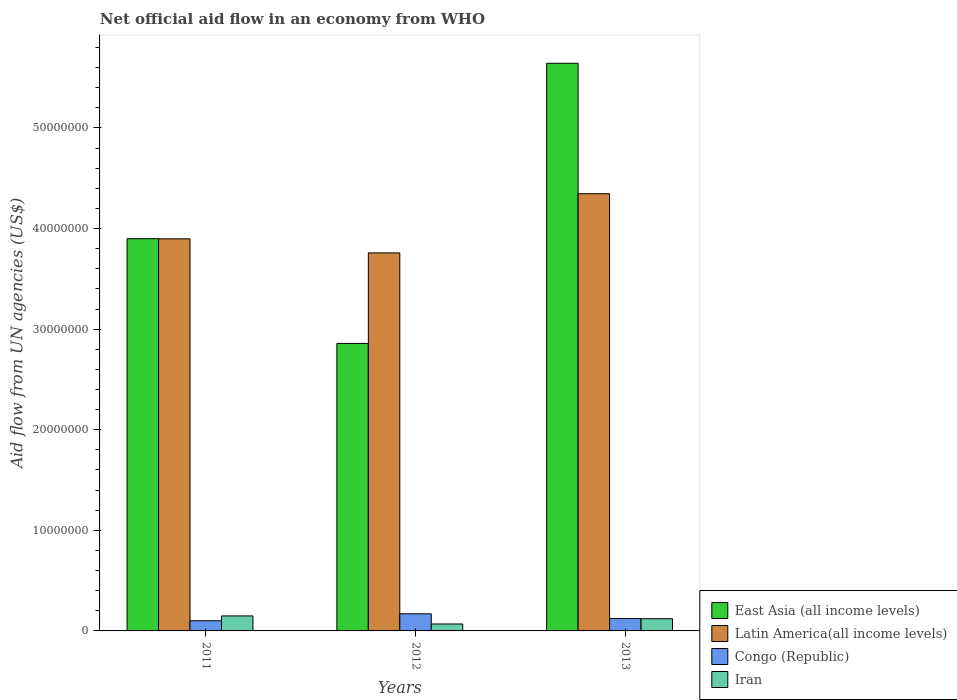How many different coloured bars are there?
Offer a terse response. 4. How many bars are there on the 1st tick from the right?
Your response must be concise. 4. What is the net official aid flow in Latin America(all income levels) in 2011?
Your answer should be compact. 3.90e+07. Across all years, what is the maximum net official aid flow in Iran?
Provide a succinct answer. 1.49e+06. Across all years, what is the minimum net official aid flow in Congo (Republic)?
Your answer should be very brief. 1.01e+06. In which year was the net official aid flow in Iran maximum?
Make the answer very short. 2011. In which year was the net official aid flow in Congo (Republic) minimum?
Your response must be concise. 2011. What is the total net official aid flow in Iran in the graph?
Your response must be concise. 3.39e+06. What is the difference between the net official aid flow in Congo (Republic) in 2011 and that in 2012?
Ensure brevity in your answer.  -6.90e+05. What is the difference between the net official aid flow in Congo (Republic) in 2011 and the net official aid flow in Latin America(all income levels) in 2012?
Provide a succinct answer. -3.66e+07. What is the average net official aid flow in East Asia (all income levels) per year?
Make the answer very short. 4.13e+07. In the year 2013, what is the difference between the net official aid flow in East Asia (all income levels) and net official aid flow in Iran?
Provide a short and direct response. 5.52e+07. What is the ratio of the net official aid flow in Latin America(all income levels) in 2011 to that in 2013?
Offer a very short reply. 0.9. Is the net official aid flow in East Asia (all income levels) in 2012 less than that in 2013?
Your response must be concise. Yes. Is the difference between the net official aid flow in East Asia (all income levels) in 2011 and 2013 greater than the difference between the net official aid flow in Iran in 2011 and 2013?
Keep it short and to the point. No. What is the difference between the highest and the second highest net official aid flow in Congo (Republic)?
Give a very brief answer. 4.70e+05. What is the difference between the highest and the lowest net official aid flow in Iran?
Your answer should be compact. 8.00e+05. Is it the case that in every year, the sum of the net official aid flow in Congo (Republic) and net official aid flow in Latin America(all income levels) is greater than the sum of net official aid flow in East Asia (all income levels) and net official aid flow in Iran?
Offer a terse response. Yes. What does the 3rd bar from the left in 2012 represents?
Your response must be concise. Congo (Republic). What does the 2nd bar from the right in 2012 represents?
Provide a succinct answer. Congo (Republic). How many years are there in the graph?
Provide a short and direct response. 3. Does the graph contain any zero values?
Keep it short and to the point. No. Does the graph contain grids?
Your answer should be compact. No. What is the title of the graph?
Make the answer very short. Net official aid flow in an economy from WHO. What is the label or title of the Y-axis?
Offer a very short reply. Aid flow from UN agencies (US$). What is the Aid flow from UN agencies (US$) in East Asia (all income levels) in 2011?
Your answer should be compact. 3.90e+07. What is the Aid flow from UN agencies (US$) in Latin America(all income levels) in 2011?
Ensure brevity in your answer.  3.90e+07. What is the Aid flow from UN agencies (US$) of Congo (Republic) in 2011?
Keep it short and to the point. 1.01e+06. What is the Aid flow from UN agencies (US$) of Iran in 2011?
Your answer should be very brief. 1.49e+06. What is the Aid flow from UN agencies (US$) in East Asia (all income levels) in 2012?
Ensure brevity in your answer.  2.86e+07. What is the Aid flow from UN agencies (US$) in Latin America(all income levels) in 2012?
Keep it short and to the point. 3.76e+07. What is the Aid flow from UN agencies (US$) in Congo (Republic) in 2012?
Provide a short and direct response. 1.70e+06. What is the Aid flow from UN agencies (US$) in Iran in 2012?
Your answer should be very brief. 6.90e+05. What is the Aid flow from UN agencies (US$) of East Asia (all income levels) in 2013?
Offer a very short reply. 5.64e+07. What is the Aid flow from UN agencies (US$) in Latin America(all income levels) in 2013?
Make the answer very short. 4.35e+07. What is the Aid flow from UN agencies (US$) of Congo (Republic) in 2013?
Offer a very short reply. 1.23e+06. What is the Aid flow from UN agencies (US$) in Iran in 2013?
Your answer should be very brief. 1.21e+06. Across all years, what is the maximum Aid flow from UN agencies (US$) in East Asia (all income levels)?
Your answer should be compact. 5.64e+07. Across all years, what is the maximum Aid flow from UN agencies (US$) in Latin America(all income levels)?
Give a very brief answer. 4.35e+07. Across all years, what is the maximum Aid flow from UN agencies (US$) in Congo (Republic)?
Your answer should be very brief. 1.70e+06. Across all years, what is the maximum Aid flow from UN agencies (US$) of Iran?
Give a very brief answer. 1.49e+06. Across all years, what is the minimum Aid flow from UN agencies (US$) of East Asia (all income levels)?
Provide a short and direct response. 2.86e+07. Across all years, what is the minimum Aid flow from UN agencies (US$) in Latin America(all income levels)?
Ensure brevity in your answer.  3.76e+07. Across all years, what is the minimum Aid flow from UN agencies (US$) of Congo (Republic)?
Your response must be concise. 1.01e+06. Across all years, what is the minimum Aid flow from UN agencies (US$) in Iran?
Offer a very short reply. 6.90e+05. What is the total Aid flow from UN agencies (US$) of East Asia (all income levels) in the graph?
Give a very brief answer. 1.24e+08. What is the total Aid flow from UN agencies (US$) of Latin America(all income levels) in the graph?
Make the answer very short. 1.20e+08. What is the total Aid flow from UN agencies (US$) in Congo (Republic) in the graph?
Provide a short and direct response. 3.94e+06. What is the total Aid flow from UN agencies (US$) of Iran in the graph?
Ensure brevity in your answer.  3.39e+06. What is the difference between the Aid flow from UN agencies (US$) of East Asia (all income levels) in 2011 and that in 2012?
Give a very brief answer. 1.04e+07. What is the difference between the Aid flow from UN agencies (US$) in Latin America(all income levels) in 2011 and that in 2012?
Your answer should be very brief. 1.40e+06. What is the difference between the Aid flow from UN agencies (US$) of Congo (Republic) in 2011 and that in 2012?
Ensure brevity in your answer.  -6.90e+05. What is the difference between the Aid flow from UN agencies (US$) of East Asia (all income levels) in 2011 and that in 2013?
Make the answer very short. -1.74e+07. What is the difference between the Aid flow from UN agencies (US$) in Latin America(all income levels) in 2011 and that in 2013?
Ensure brevity in your answer.  -4.48e+06. What is the difference between the Aid flow from UN agencies (US$) of Congo (Republic) in 2011 and that in 2013?
Provide a short and direct response. -2.20e+05. What is the difference between the Aid flow from UN agencies (US$) of Iran in 2011 and that in 2013?
Offer a terse response. 2.80e+05. What is the difference between the Aid flow from UN agencies (US$) of East Asia (all income levels) in 2012 and that in 2013?
Your response must be concise. -2.78e+07. What is the difference between the Aid flow from UN agencies (US$) of Latin America(all income levels) in 2012 and that in 2013?
Offer a very short reply. -5.88e+06. What is the difference between the Aid flow from UN agencies (US$) in Iran in 2012 and that in 2013?
Offer a very short reply. -5.20e+05. What is the difference between the Aid flow from UN agencies (US$) of East Asia (all income levels) in 2011 and the Aid flow from UN agencies (US$) of Latin America(all income levels) in 2012?
Provide a succinct answer. 1.41e+06. What is the difference between the Aid flow from UN agencies (US$) of East Asia (all income levels) in 2011 and the Aid flow from UN agencies (US$) of Congo (Republic) in 2012?
Offer a terse response. 3.73e+07. What is the difference between the Aid flow from UN agencies (US$) of East Asia (all income levels) in 2011 and the Aid flow from UN agencies (US$) of Iran in 2012?
Provide a short and direct response. 3.83e+07. What is the difference between the Aid flow from UN agencies (US$) in Latin America(all income levels) in 2011 and the Aid flow from UN agencies (US$) in Congo (Republic) in 2012?
Make the answer very short. 3.73e+07. What is the difference between the Aid flow from UN agencies (US$) of Latin America(all income levels) in 2011 and the Aid flow from UN agencies (US$) of Iran in 2012?
Your response must be concise. 3.83e+07. What is the difference between the Aid flow from UN agencies (US$) in East Asia (all income levels) in 2011 and the Aid flow from UN agencies (US$) in Latin America(all income levels) in 2013?
Your response must be concise. -4.47e+06. What is the difference between the Aid flow from UN agencies (US$) in East Asia (all income levels) in 2011 and the Aid flow from UN agencies (US$) in Congo (Republic) in 2013?
Offer a very short reply. 3.78e+07. What is the difference between the Aid flow from UN agencies (US$) of East Asia (all income levels) in 2011 and the Aid flow from UN agencies (US$) of Iran in 2013?
Provide a succinct answer. 3.78e+07. What is the difference between the Aid flow from UN agencies (US$) of Latin America(all income levels) in 2011 and the Aid flow from UN agencies (US$) of Congo (Republic) in 2013?
Provide a short and direct response. 3.78e+07. What is the difference between the Aid flow from UN agencies (US$) of Latin America(all income levels) in 2011 and the Aid flow from UN agencies (US$) of Iran in 2013?
Ensure brevity in your answer.  3.78e+07. What is the difference between the Aid flow from UN agencies (US$) in East Asia (all income levels) in 2012 and the Aid flow from UN agencies (US$) in Latin America(all income levels) in 2013?
Provide a short and direct response. -1.49e+07. What is the difference between the Aid flow from UN agencies (US$) of East Asia (all income levels) in 2012 and the Aid flow from UN agencies (US$) of Congo (Republic) in 2013?
Your answer should be compact. 2.74e+07. What is the difference between the Aid flow from UN agencies (US$) in East Asia (all income levels) in 2012 and the Aid flow from UN agencies (US$) in Iran in 2013?
Offer a very short reply. 2.74e+07. What is the difference between the Aid flow from UN agencies (US$) of Latin America(all income levels) in 2012 and the Aid flow from UN agencies (US$) of Congo (Republic) in 2013?
Offer a terse response. 3.64e+07. What is the difference between the Aid flow from UN agencies (US$) in Latin America(all income levels) in 2012 and the Aid flow from UN agencies (US$) in Iran in 2013?
Offer a very short reply. 3.64e+07. What is the average Aid flow from UN agencies (US$) of East Asia (all income levels) per year?
Your answer should be very brief. 4.13e+07. What is the average Aid flow from UN agencies (US$) of Latin America(all income levels) per year?
Your response must be concise. 4.00e+07. What is the average Aid flow from UN agencies (US$) in Congo (Republic) per year?
Your answer should be compact. 1.31e+06. What is the average Aid flow from UN agencies (US$) of Iran per year?
Make the answer very short. 1.13e+06. In the year 2011, what is the difference between the Aid flow from UN agencies (US$) of East Asia (all income levels) and Aid flow from UN agencies (US$) of Latin America(all income levels)?
Make the answer very short. 10000. In the year 2011, what is the difference between the Aid flow from UN agencies (US$) in East Asia (all income levels) and Aid flow from UN agencies (US$) in Congo (Republic)?
Provide a succinct answer. 3.80e+07. In the year 2011, what is the difference between the Aid flow from UN agencies (US$) of East Asia (all income levels) and Aid flow from UN agencies (US$) of Iran?
Ensure brevity in your answer.  3.75e+07. In the year 2011, what is the difference between the Aid flow from UN agencies (US$) of Latin America(all income levels) and Aid flow from UN agencies (US$) of Congo (Republic)?
Your answer should be very brief. 3.80e+07. In the year 2011, what is the difference between the Aid flow from UN agencies (US$) of Latin America(all income levels) and Aid flow from UN agencies (US$) of Iran?
Your answer should be compact. 3.75e+07. In the year 2011, what is the difference between the Aid flow from UN agencies (US$) of Congo (Republic) and Aid flow from UN agencies (US$) of Iran?
Give a very brief answer. -4.80e+05. In the year 2012, what is the difference between the Aid flow from UN agencies (US$) of East Asia (all income levels) and Aid flow from UN agencies (US$) of Latin America(all income levels)?
Provide a short and direct response. -9.00e+06. In the year 2012, what is the difference between the Aid flow from UN agencies (US$) in East Asia (all income levels) and Aid flow from UN agencies (US$) in Congo (Republic)?
Your answer should be very brief. 2.69e+07. In the year 2012, what is the difference between the Aid flow from UN agencies (US$) of East Asia (all income levels) and Aid flow from UN agencies (US$) of Iran?
Your response must be concise. 2.79e+07. In the year 2012, what is the difference between the Aid flow from UN agencies (US$) of Latin America(all income levels) and Aid flow from UN agencies (US$) of Congo (Republic)?
Provide a short and direct response. 3.59e+07. In the year 2012, what is the difference between the Aid flow from UN agencies (US$) of Latin America(all income levels) and Aid flow from UN agencies (US$) of Iran?
Make the answer very short. 3.69e+07. In the year 2012, what is the difference between the Aid flow from UN agencies (US$) in Congo (Republic) and Aid flow from UN agencies (US$) in Iran?
Offer a terse response. 1.01e+06. In the year 2013, what is the difference between the Aid flow from UN agencies (US$) in East Asia (all income levels) and Aid flow from UN agencies (US$) in Latin America(all income levels)?
Offer a terse response. 1.30e+07. In the year 2013, what is the difference between the Aid flow from UN agencies (US$) of East Asia (all income levels) and Aid flow from UN agencies (US$) of Congo (Republic)?
Provide a succinct answer. 5.52e+07. In the year 2013, what is the difference between the Aid flow from UN agencies (US$) of East Asia (all income levels) and Aid flow from UN agencies (US$) of Iran?
Offer a very short reply. 5.52e+07. In the year 2013, what is the difference between the Aid flow from UN agencies (US$) of Latin America(all income levels) and Aid flow from UN agencies (US$) of Congo (Republic)?
Offer a very short reply. 4.22e+07. In the year 2013, what is the difference between the Aid flow from UN agencies (US$) of Latin America(all income levels) and Aid flow from UN agencies (US$) of Iran?
Your response must be concise. 4.22e+07. What is the ratio of the Aid flow from UN agencies (US$) in East Asia (all income levels) in 2011 to that in 2012?
Provide a short and direct response. 1.36. What is the ratio of the Aid flow from UN agencies (US$) in Latin America(all income levels) in 2011 to that in 2012?
Offer a terse response. 1.04. What is the ratio of the Aid flow from UN agencies (US$) of Congo (Republic) in 2011 to that in 2012?
Ensure brevity in your answer.  0.59. What is the ratio of the Aid flow from UN agencies (US$) of Iran in 2011 to that in 2012?
Provide a succinct answer. 2.16. What is the ratio of the Aid flow from UN agencies (US$) in East Asia (all income levels) in 2011 to that in 2013?
Offer a very short reply. 0.69. What is the ratio of the Aid flow from UN agencies (US$) of Latin America(all income levels) in 2011 to that in 2013?
Ensure brevity in your answer.  0.9. What is the ratio of the Aid flow from UN agencies (US$) of Congo (Republic) in 2011 to that in 2013?
Your answer should be compact. 0.82. What is the ratio of the Aid flow from UN agencies (US$) of Iran in 2011 to that in 2013?
Provide a succinct answer. 1.23. What is the ratio of the Aid flow from UN agencies (US$) of East Asia (all income levels) in 2012 to that in 2013?
Give a very brief answer. 0.51. What is the ratio of the Aid flow from UN agencies (US$) of Latin America(all income levels) in 2012 to that in 2013?
Keep it short and to the point. 0.86. What is the ratio of the Aid flow from UN agencies (US$) of Congo (Republic) in 2012 to that in 2013?
Provide a short and direct response. 1.38. What is the ratio of the Aid flow from UN agencies (US$) of Iran in 2012 to that in 2013?
Your answer should be very brief. 0.57. What is the difference between the highest and the second highest Aid flow from UN agencies (US$) of East Asia (all income levels)?
Offer a terse response. 1.74e+07. What is the difference between the highest and the second highest Aid flow from UN agencies (US$) in Latin America(all income levels)?
Give a very brief answer. 4.48e+06. What is the difference between the highest and the second highest Aid flow from UN agencies (US$) in Iran?
Provide a short and direct response. 2.80e+05. What is the difference between the highest and the lowest Aid flow from UN agencies (US$) of East Asia (all income levels)?
Your answer should be compact. 2.78e+07. What is the difference between the highest and the lowest Aid flow from UN agencies (US$) of Latin America(all income levels)?
Your answer should be very brief. 5.88e+06. What is the difference between the highest and the lowest Aid flow from UN agencies (US$) in Congo (Republic)?
Provide a short and direct response. 6.90e+05. What is the difference between the highest and the lowest Aid flow from UN agencies (US$) of Iran?
Provide a succinct answer. 8.00e+05. 